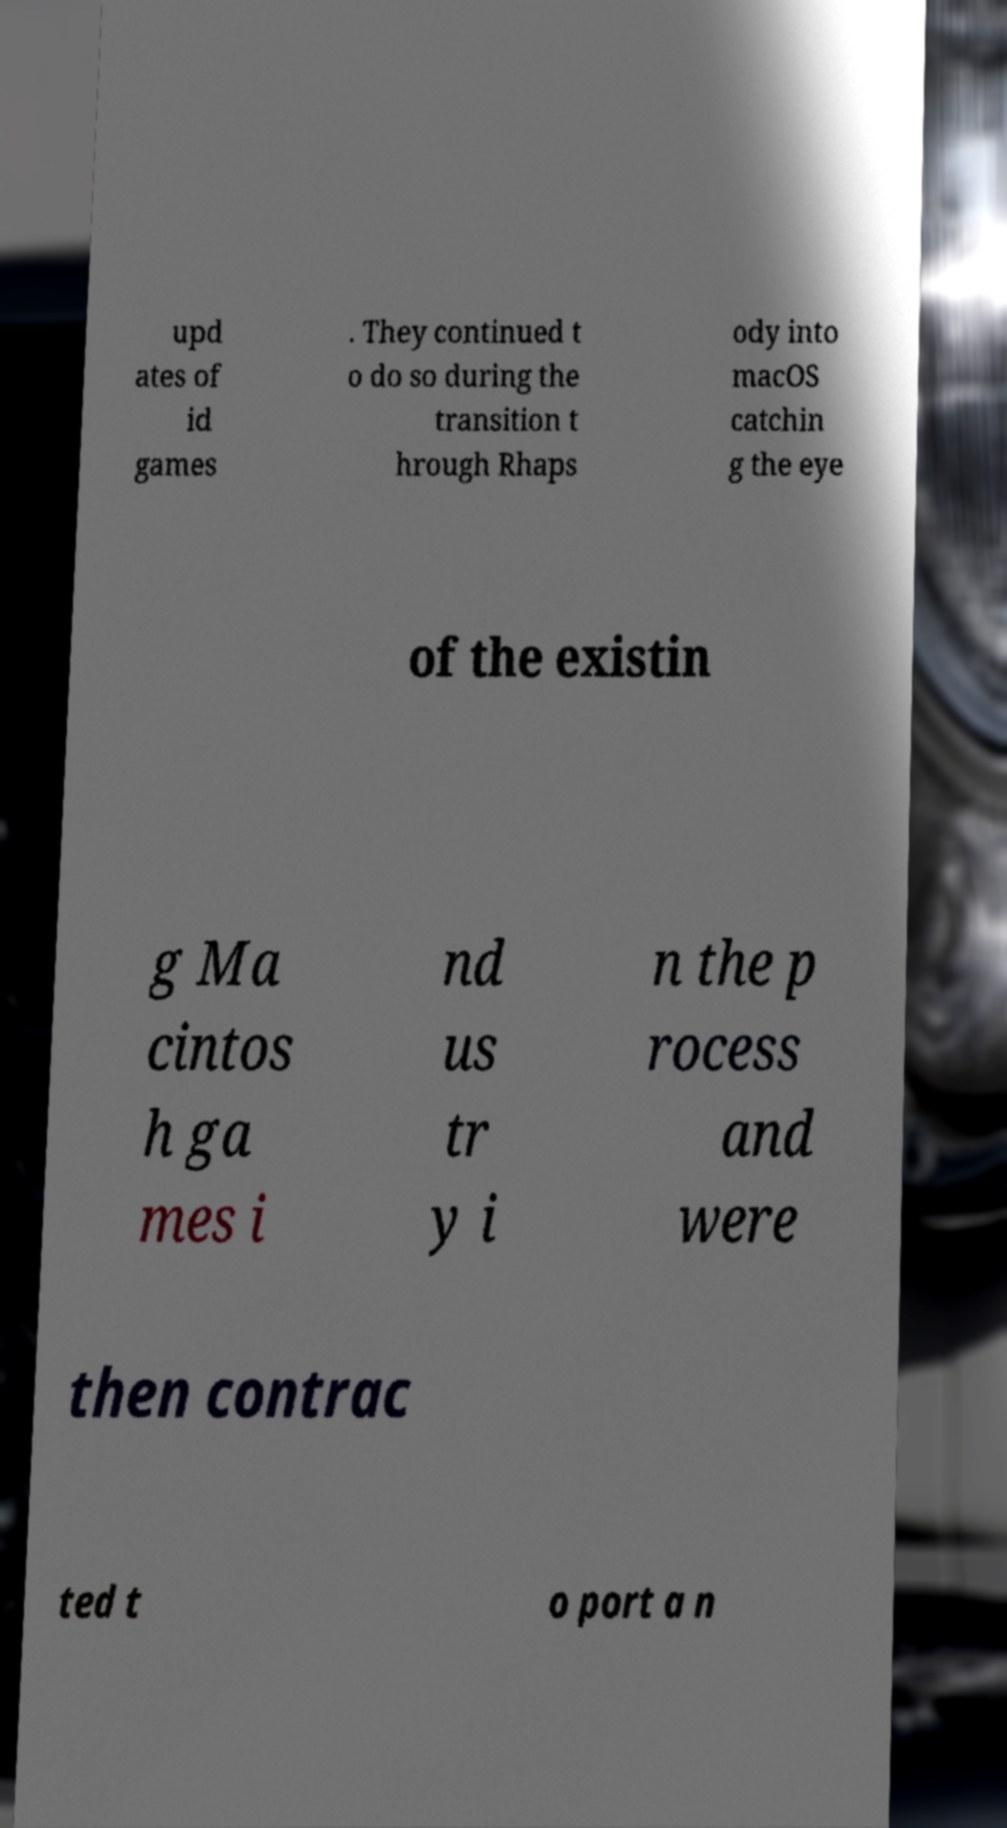Please identify and transcribe the text found in this image. upd ates of id games . They continued t o do so during the transition t hrough Rhaps ody into macOS catchin g the eye of the existin g Ma cintos h ga mes i nd us tr y i n the p rocess and were then contrac ted t o port a n 